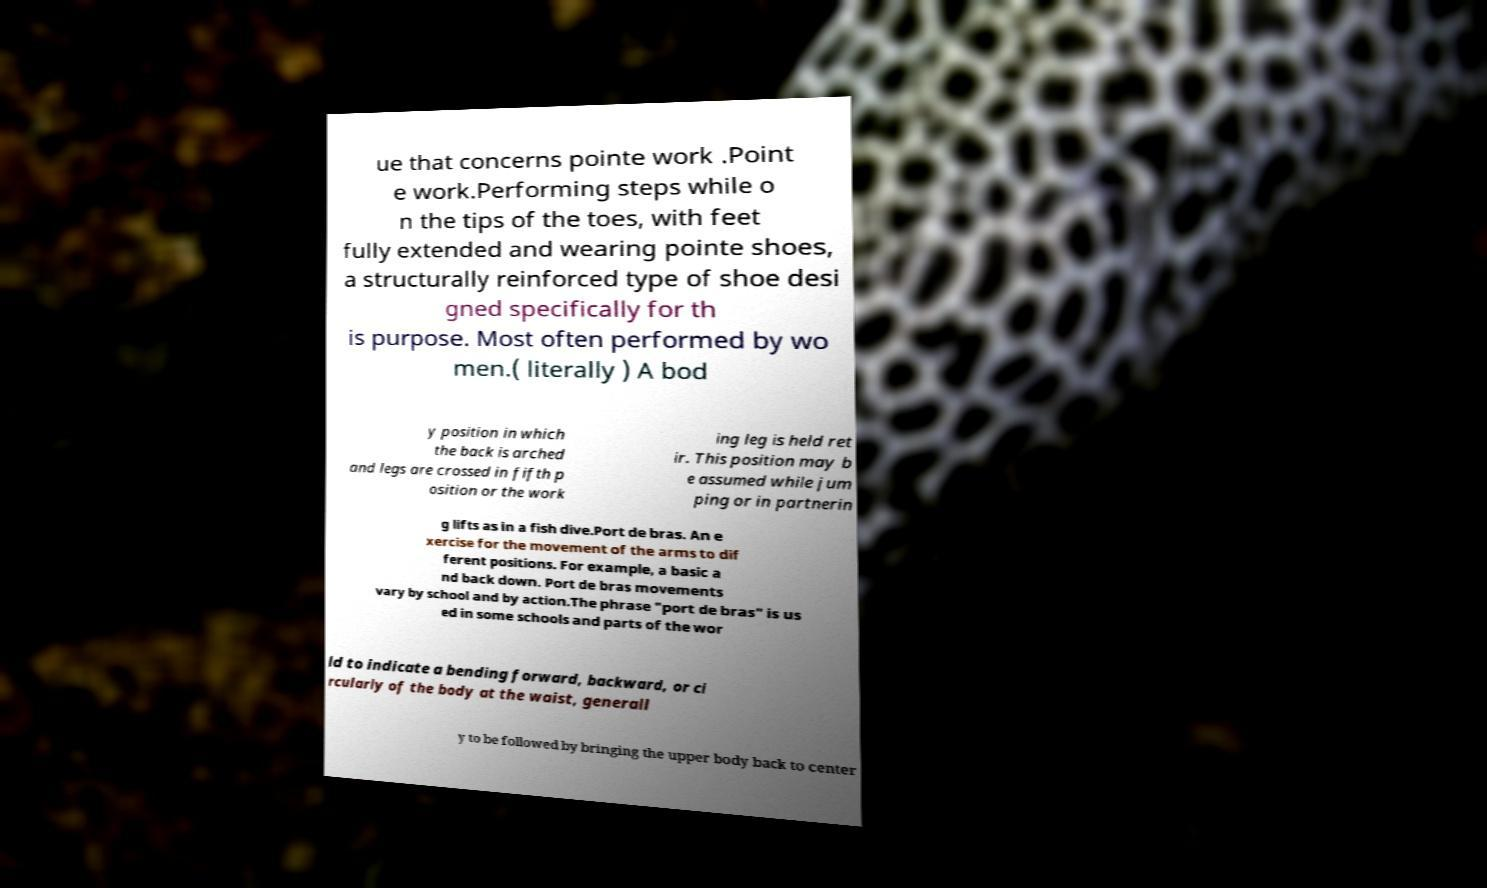I need the written content from this picture converted into text. Can you do that? ue that concerns pointe work .Point e work.Performing steps while o n the tips of the toes, with feet fully extended and wearing pointe shoes, a structurally reinforced type of shoe desi gned specifically for th is purpose. Most often performed by wo men.( literally ) A bod y position in which the back is arched and legs are crossed in fifth p osition or the work ing leg is held ret ir. This position may b e assumed while jum ping or in partnerin g lifts as in a fish dive.Port de bras. An e xercise for the movement of the arms to dif ferent positions. For example, a basic a nd back down. Port de bras movements vary by school and by action.The phrase "port de bras" is us ed in some schools and parts of the wor ld to indicate a bending forward, backward, or ci rcularly of the body at the waist, generall y to be followed by bringing the upper body back to center 